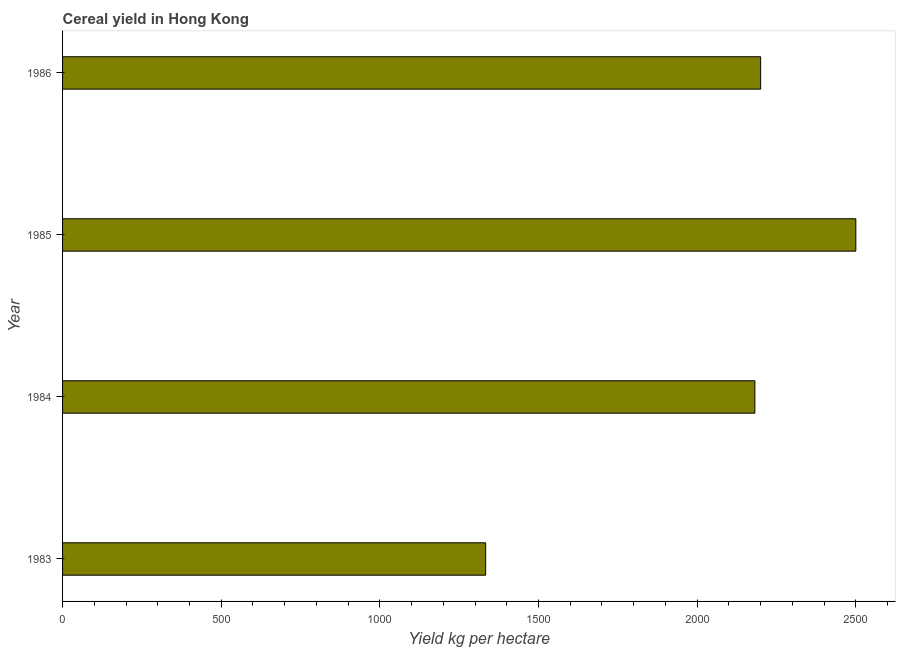What is the title of the graph?
Provide a succinct answer. Cereal yield in Hong Kong. What is the label or title of the X-axis?
Ensure brevity in your answer.  Yield kg per hectare. What is the cereal yield in 1986?
Give a very brief answer. 2200. Across all years, what is the maximum cereal yield?
Give a very brief answer. 2500. Across all years, what is the minimum cereal yield?
Provide a succinct answer. 1333.33. In which year was the cereal yield minimum?
Provide a succinct answer. 1983. What is the sum of the cereal yield?
Make the answer very short. 8215.15. What is the difference between the cereal yield in 1983 and 1984?
Your answer should be compact. -848.49. What is the average cereal yield per year?
Ensure brevity in your answer.  2053.79. What is the median cereal yield?
Your answer should be very brief. 2190.91. In how many years, is the cereal yield greater than 1000 kg per hectare?
Provide a succinct answer. 4. What is the ratio of the cereal yield in 1985 to that in 1986?
Your response must be concise. 1.14. Is the cereal yield in 1984 less than that in 1985?
Offer a very short reply. Yes. Is the difference between the cereal yield in 1983 and 1986 greater than the difference between any two years?
Give a very brief answer. No. What is the difference between the highest and the second highest cereal yield?
Your answer should be compact. 300. What is the difference between the highest and the lowest cereal yield?
Give a very brief answer. 1166.67. In how many years, is the cereal yield greater than the average cereal yield taken over all years?
Provide a short and direct response. 3. Are all the bars in the graph horizontal?
Offer a very short reply. Yes. How many years are there in the graph?
Ensure brevity in your answer.  4. What is the difference between two consecutive major ticks on the X-axis?
Ensure brevity in your answer.  500. Are the values on the major ticks of X-axis written in scientific E-notation?
Provide a short and direct response. No. What is the Yield kg per hectare of 1983?
Your answer should be compact. 1333.33. What is the Yield kg per hectare in 1984?
Keep it short and to the point. 2181.82. What is the Yield kg per hectare of 1985?
Provide a short and direct response. 2500. What is the Yield kg per hectare of 1986?
Provide a short and direct response. 2200. What is the difference between the Yield kg per hectare in 1983 and 1984?
Keep it short and to the point. -848.49. What is the difference between the Yield kg per hectare in 1983 and 1985?
Your answer should be very brief. -1166.67. What is the difference between the Yield kg per hectare in 1983 and 1986?
Your answer should be compact. -866.67. What is the difference between the Yield kg per hectare in 1984 and 1985?
Your answer should be compact. -318.18. What is the difference between the Yield kg per hectare in 1984 and 1986?
Your answer should be compact. -18.18. What is the difference between the Yield kg per hectare in 1985 and 1986?
Provide a succinct answer. 300. What is the ratio of the Yield kg per hectare in 1983 to that in 1984?
Give a very brief answer. 0.61. What is the ratio of the Yield kg per hectare in 1983 to that in 1985?
Offer a very short reply. 0.53. What is the ratio of the Yield kg per hectare in 1983 to that in 1986?
Your answer should be compact. 0.61. What is the ratio of the Yield kg per hectare in 1984 to that in 1985?
Your answer should be compact. 0.87. What is the ratio of the Yield kg per hectare in 1984 to that in 1986?
Provide a succinct answer. 0.99. What is the ratio of the Yield kg per hectare in 1985 to that in 1986?
Your answer should be very brief. 1.14. 